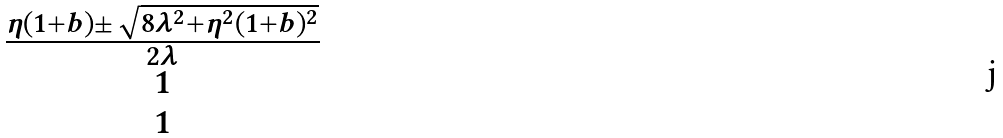Convert formula to latex. <formula><loc_0><loc_0><loc_500><loc_500>\begin{matrix} \frac { \eta ( 1 + b ) \pm \sqrt { 8 \lambda ^ { 2 } + \eta ^ { 2 } ( 1 + b ) ^ { 2 } } } { 2 \lambda } \\ 1 \\ 1 \end{matrix}</formula> 